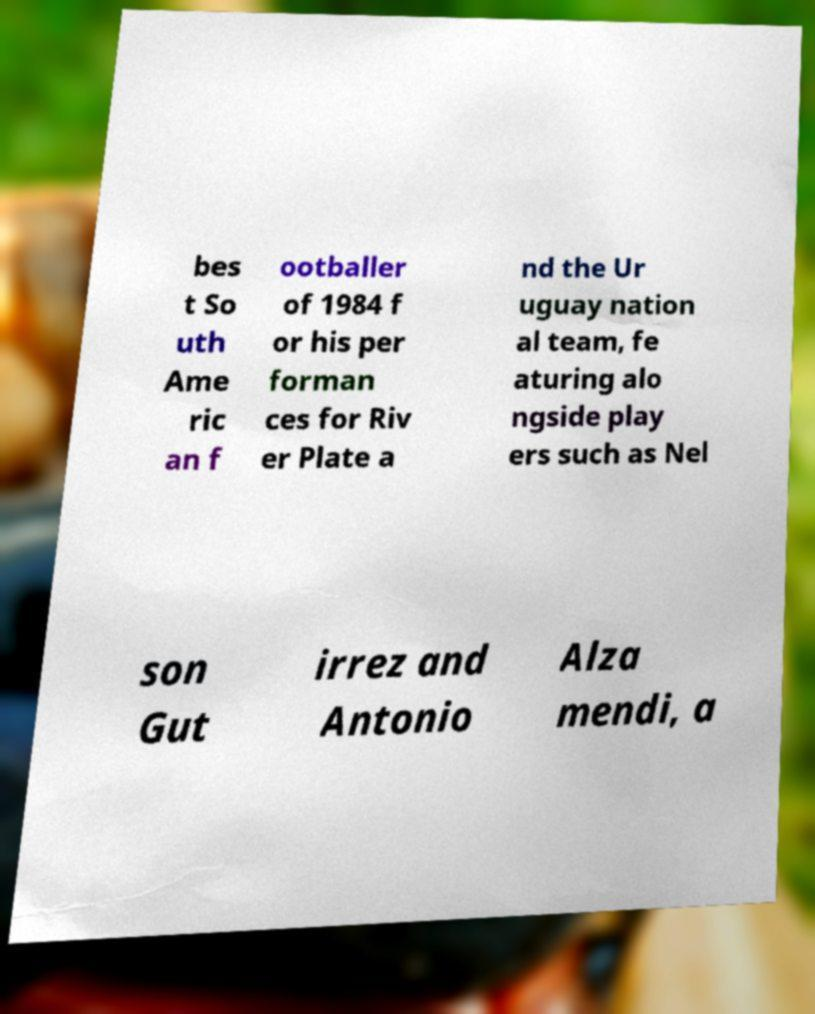For documentation purposes, I need the text within this image transcribed. Could you provide that? bes t So uth Ame ric an f ootballer of 1984 f or his per forman ces for Riv er Plate a nd the Ur uguay nation al team, fe aturing alo ngside play ers such as Nel son Gut irrez and Antonio Alza mendi, a 